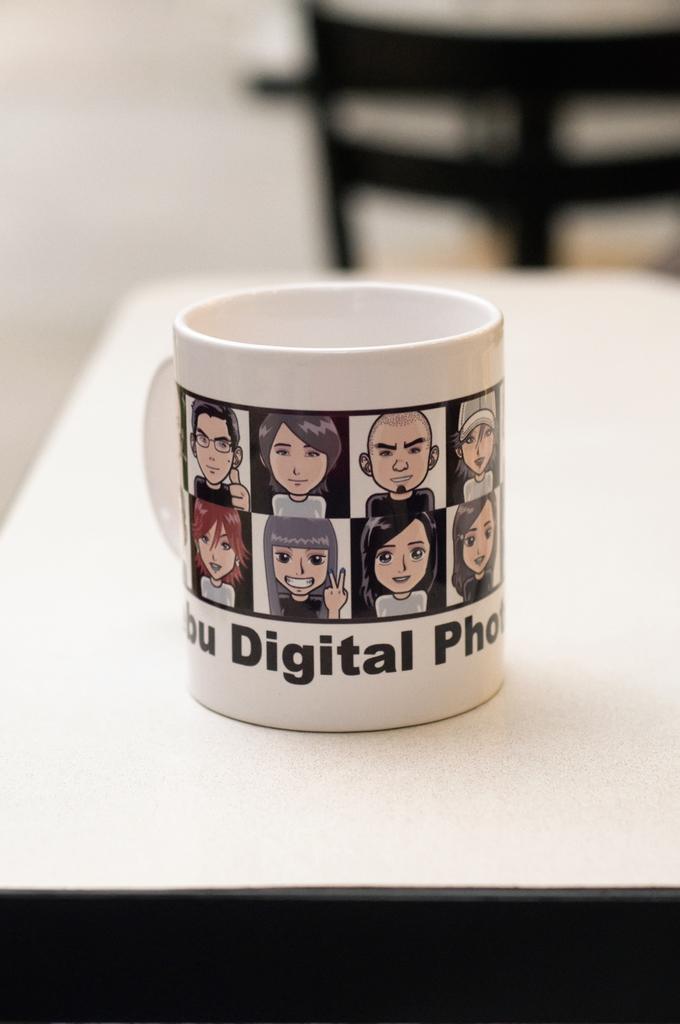Is this digitized?
Offer a very short reply. Yes. 